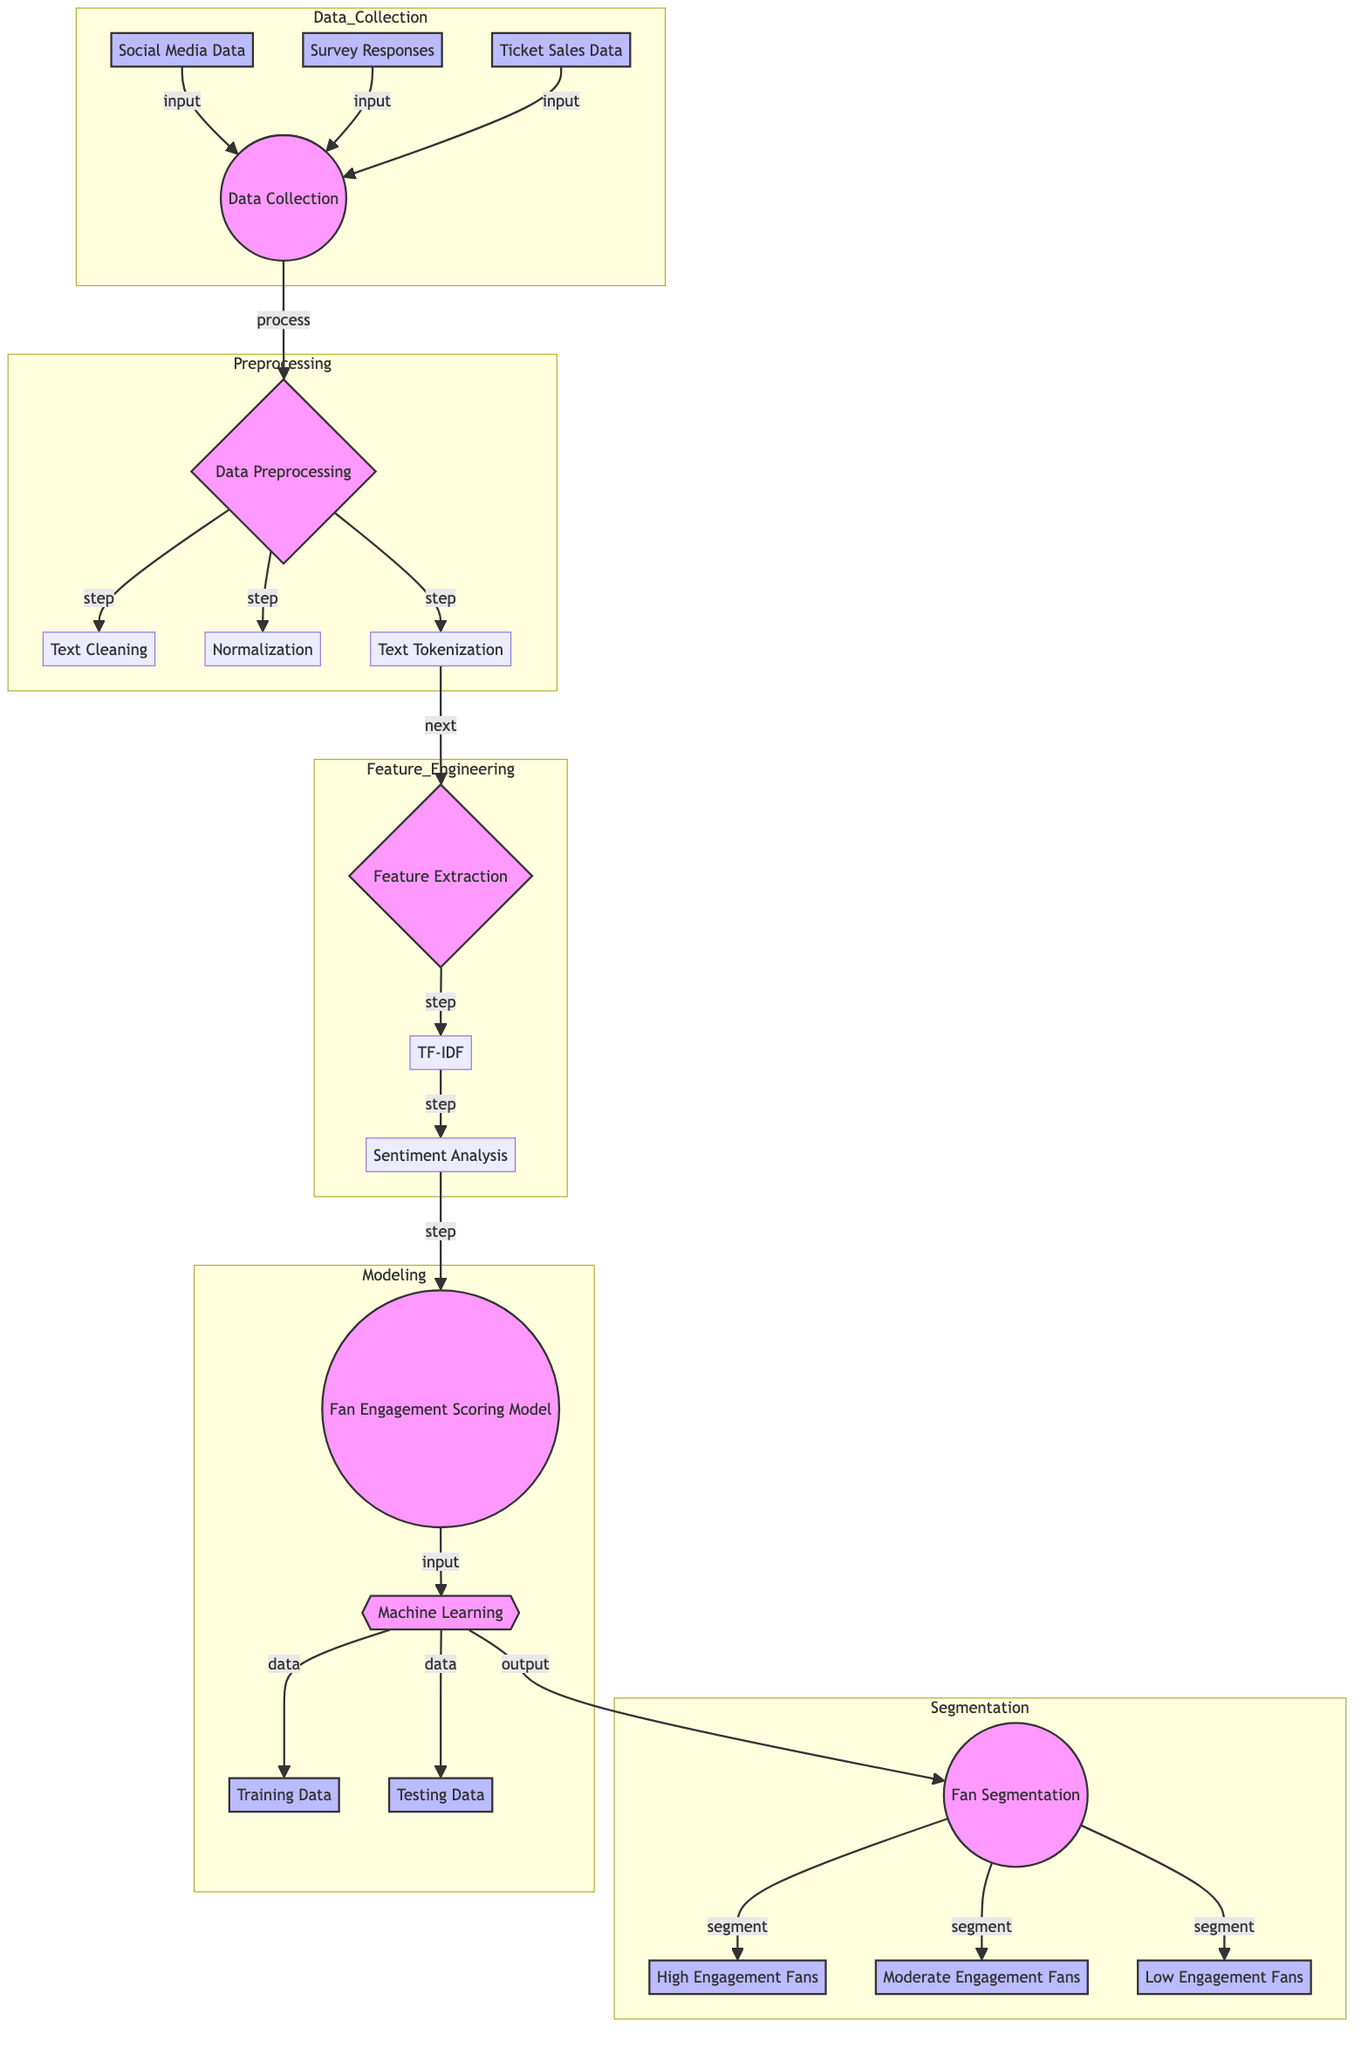What are the three types of data collected? The diagram indicates the three types of data collected as social media data, survey responses, and ticket sales data, shown in the data collection section of the diagram.
Answer: Social media data, survey responses, ticket sales data How many steps are involved in data preprocessing? The diagram outlines three distinct steps in data preprocessing: text cleaning, normalization, and text tokenization.
Answer: Three What is the first step in data preprocessing? According to the diagram, the first step in data preprocessing is text cleaning, which is indicated as the initial process in that section.
Answer: Text cleaning What is the output after the Fan Engagement Scoring Model? The output of the Fan Engagement Scoring Model leads directly to the fan segmentation process, as shown in the flow of the diagram.
Answer: Fan segmentation Which segment includes fans with high engagement? The diagram specifically shows that the high engagement fans belong to the "High Engagement Fans" segment, which is part of the fan segmentation output.
Answer: High Engagement Fans What method is used in feature extraction for sentiment analysis? In the feature extraction stage, sentiment analysis is explicitly mentioned as one of the methods used for analyzing the collected data in the diagram.
Answer: Sentiment analysis How many types of fan segments are there? The diagram displays three distinct types of fan segments: high engagement fans, moderate engagement fans, and low engagement fans, which together count to three segments.
Answer: Three What connects data collection to data preprocessing? The diagram indicates a direct connection from the data collection node to the data preprocessing node, labeled as "process," thereby establishing the flow between these two stages.
Answer: Process What is the purpose of normalization in data preprocessing? The normalization step in data preprocessing aims to standardize the collected data, making it suitable for analysis, as indicated in the diagram flow.
Answer: Standardization 